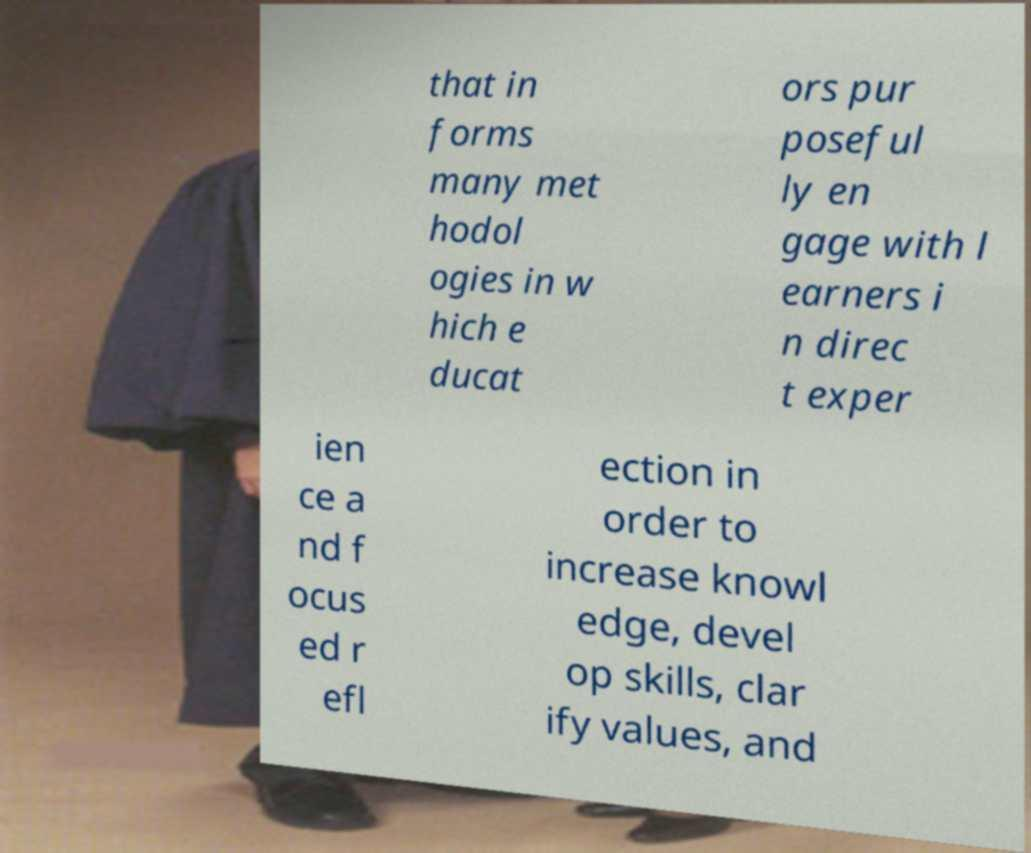For documentation purposes, I need the text within this image transcribed. Could you provide that? that in forms many met hodol ogies in w hich e ducat ors pur poseful ly en gage with l earners i n direc t exper ien ce a nd f ocus ed r efl ection in order to increase knowl edge, devel op skills, clar ify values, and 